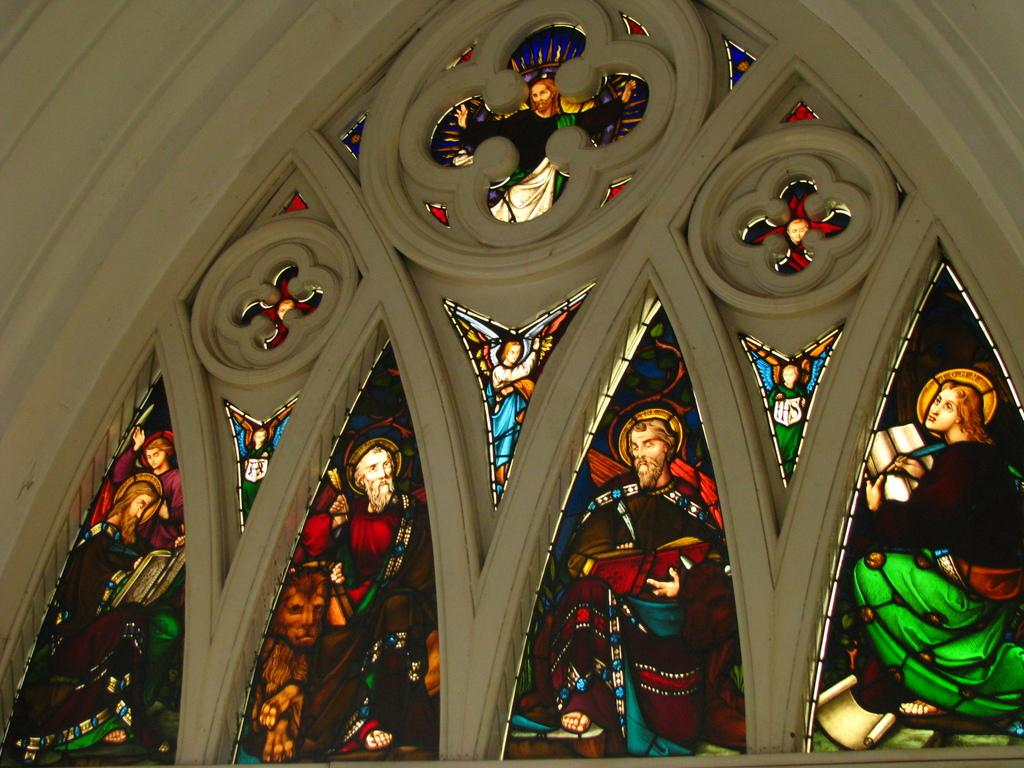What type of glass is featured in the picture? There is stained glass in the picture. What can be seen on the stained glass? The stained glass has pictures of persons. What color is the wall in the picture? There is a white color wall in the picture. How many eggs are visible on the stained glass in the image? There are no eggs visible on the stained glass in the image. What is the brain's role in the image? There is no brain present in the image. 